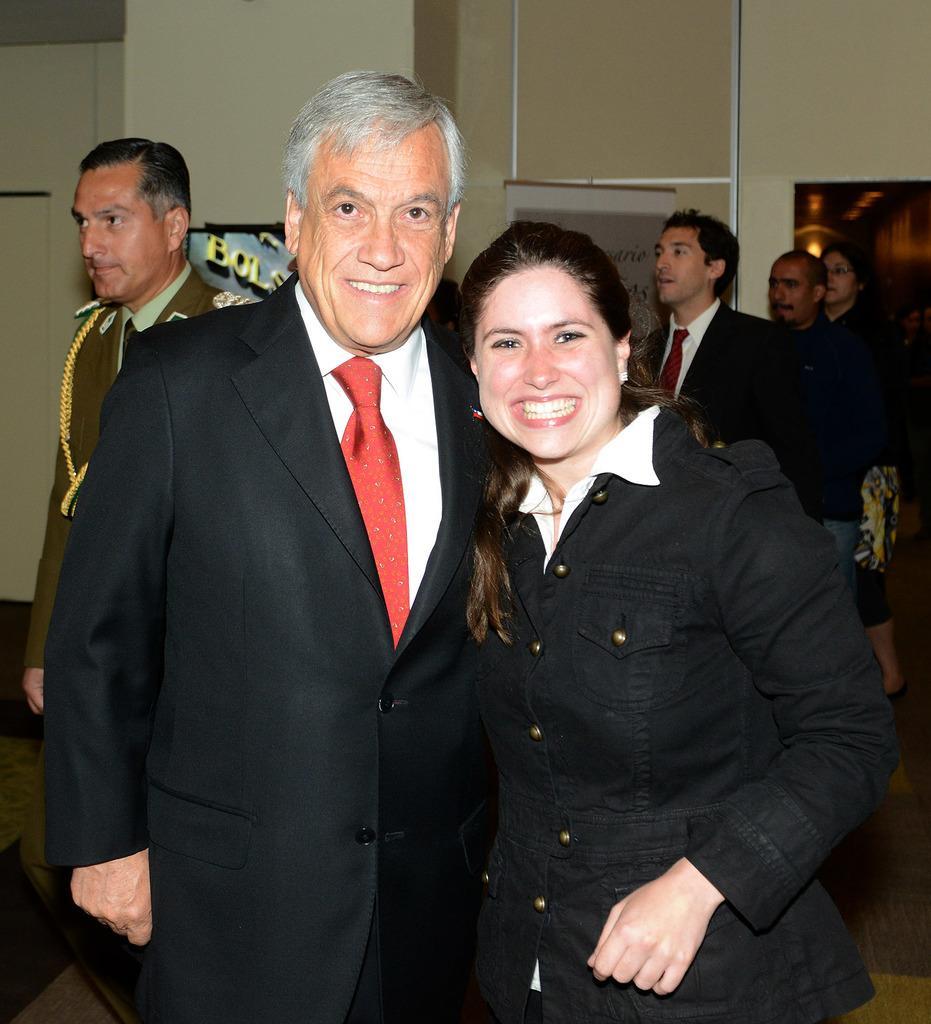Can you describe this image briefly? In this image we can see a group of people standing. On the backside we can a wall and a board with some text on it. 